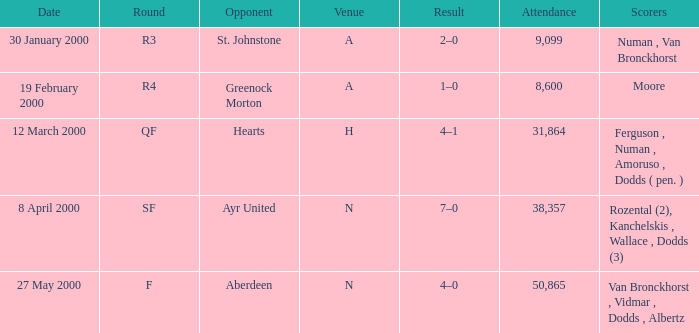Who existed on march 12, 2000? Ferguson , Numan , Amoruso , Dodds ( pen. ). 